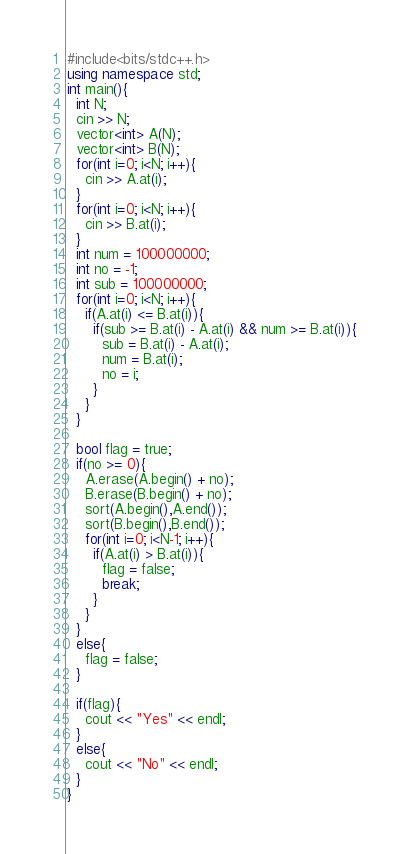<code> <loc_0><loc_0><loc_500><loc_500><_C++_>#include<bits/stdc++.h>
using namespace std;
int main(){
  int N;
  cin >> N;
  vector<int> A(N);
  vector<int> B(N);
  for(int i=0; i<N; i++){
    cin >> A.at(i);
  }
  for(int i=0; i<N; i++){
    cin >> B.at(i);
  }
  int num = 100000000;
  int no = -1;
  int sub = 100000000;
  for(int i=0; i<N; i++){
    if(A.at(i) <= B.at(i)){
      if(sub >= B.at(i) - A.at(i) && num >= B.at(i)){
        sub = B.at(i) - A.at(i);
        num = B.at(i);
        no = i;
      }
    }
  }
  
  bool flag = true;
  if(no >= 0){
    A.erase(A.begin() + no);
    B.erase(B.begin() + no);
    sort(A.begin(),A.end());
    sort(B.begin(),B.end());
    for(int i=0; i<N-1; i++){
      if(A.at(i) > B.at(i)){
        flag = false;
        break;
      }
    }
  }
  else{
    flag = false;
  }
  
  if(flag){
    cout << "Yes" << endl;
  }
  else{
    cout << "No" << endl;
  }    
}</code> 